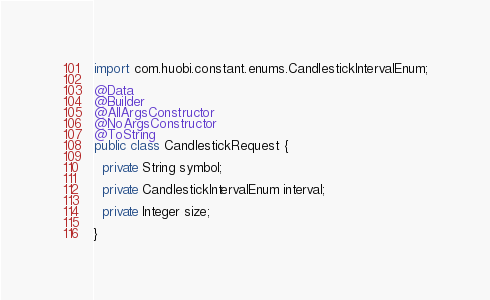Convert code to text. <code><loc_0><loc_0><loc_500><loc_500><_Java_>import com.huobi.constant.enums.CandlestickIntervalEnum;

@Data
@Builder
@AllArgsConstructor
@NoArgsConstructor
@ToString
public class CandlestickRequest {

  private String symbol;

  private CandlestickIntervalEnum interval;

  private Integer size;

}
</code> 